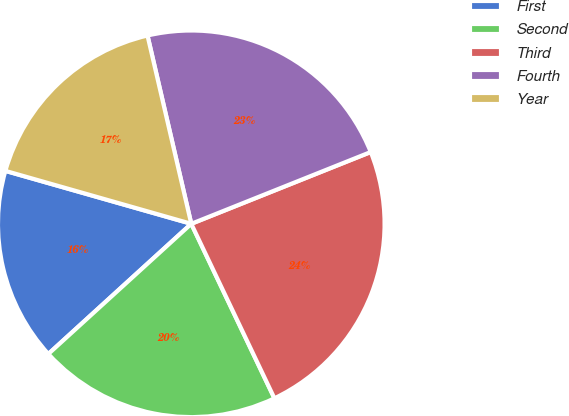Convert chart. <chart><loc_0><loc_0><loc_500><loc_500><pie_chart><fcel>First<fcel>Second<fcel>Third<fcel>Fourth<fcel>Year<nl><fcel>16.17%<fcel>20.32%<fcel>23.98%<fcel>22.58%<fcel>16.95%<nl></chart> 